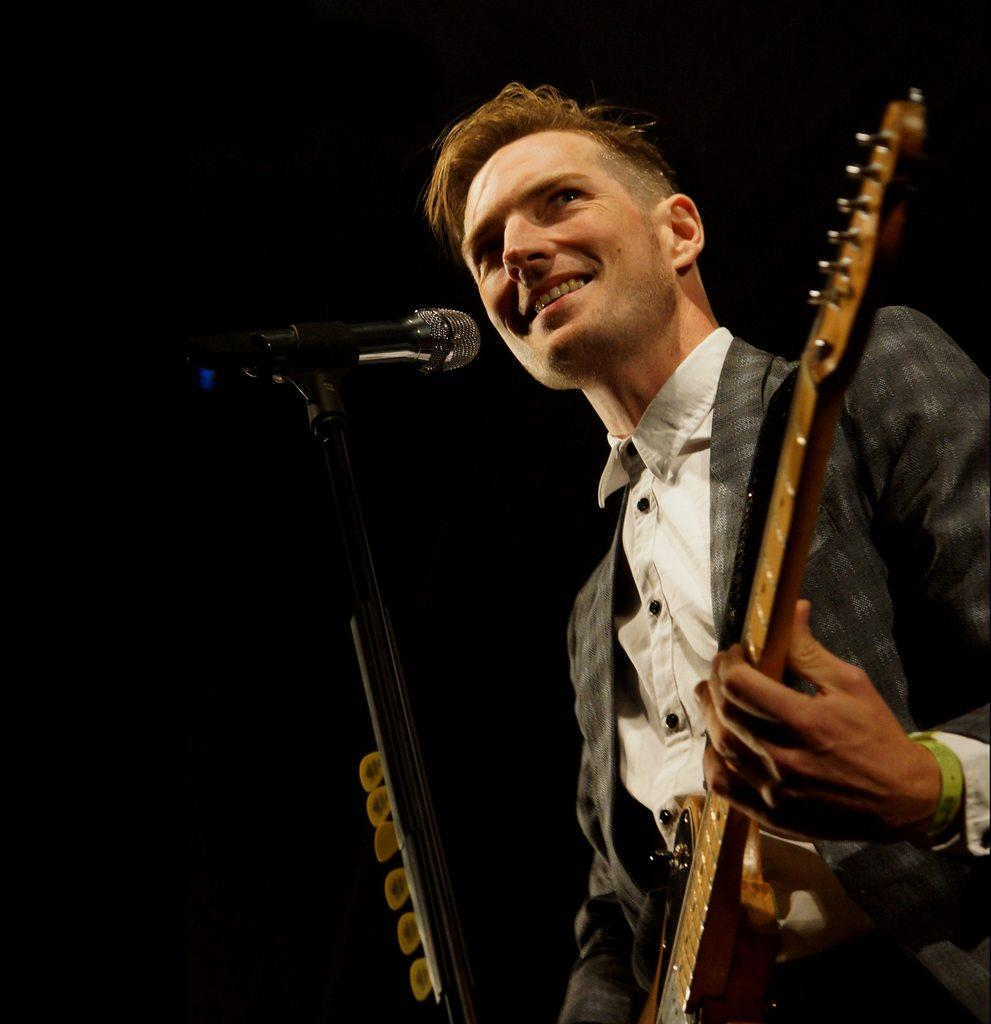What is the main subject of the image? There is a person in the image. What is the person doing in the image? The person is standing, singing a song, and playing the guitar. What object is in front of the person? There is a microphone in front of the person. What instrument is the person holding? The person is holding a guitar. What type of finger is the person using to play the guitar in the image? The image does not specify which finger the person is using to play the guitar. What type of voyage is the person embarking on in the image? There is no indication of a voyage in the image; the person is simply standing, singing, and playing the guitar. 